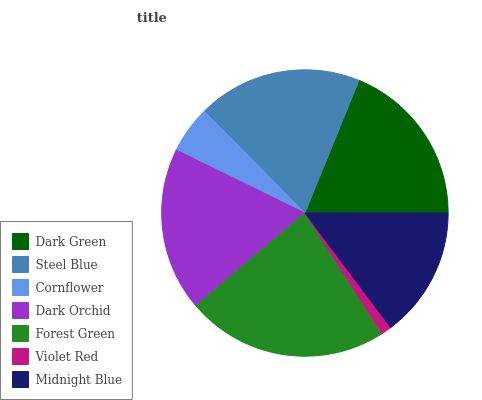Is Violet Red the minimum?
Answer yes or no. Yes. Is Forest Green the maximum?
Answer yes or no. Yes. Is Steel Blue the minimum?
Answer yes or no. No. Is Steel Blue the maximum?
Answer yes or no. No. Is Dark Green greater than Steel Blue?
Answer yes or no. Yes. Is Steel Blue less than Dark Green?
Answer yes or no. Yes. Is Steel Blue greater than Dark Green?
Answer yes or no. No. Is Dark Green less than Steel Blue?
Answer yes or no. No. Is Dark Orchid the high median?
Answer yes or no. Yes. Is Dark Orchid the low median?
Answer yes or no. Yes. Is Dark Green the high median?
Answer yes or no. No. Is Violet Red the low median?
Answer yes or no. No. 